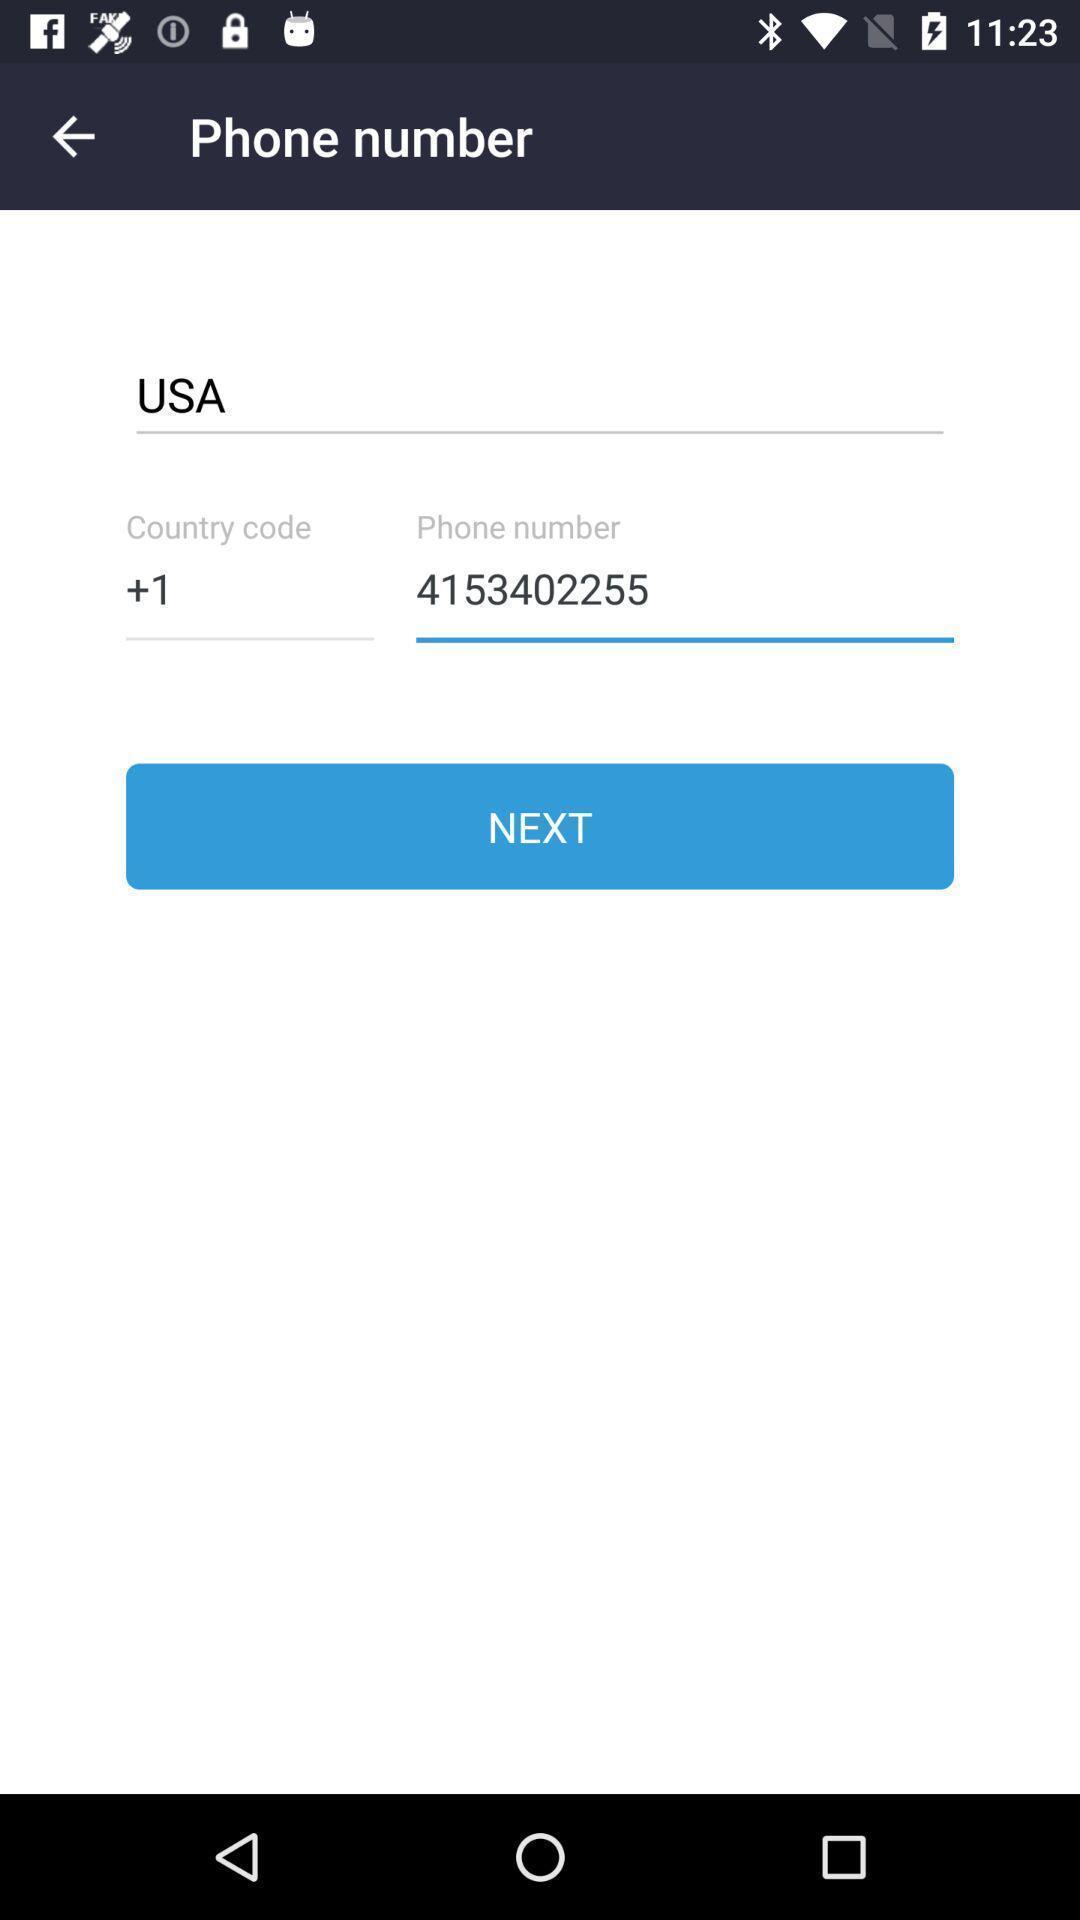Please provide a description for this image. Page to enter phone number to create an account. 